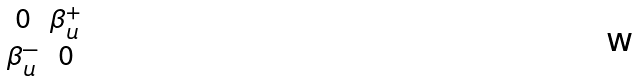Convert formula to latex. <formula><loc_0><loc_0><loc_500><loc_500>\begin{smallmatrix} 0 & \beta ^ { + } _ { u } \\ \beta ^ { - } _ { u } & 0 \end{smallmatrix}</formula> 